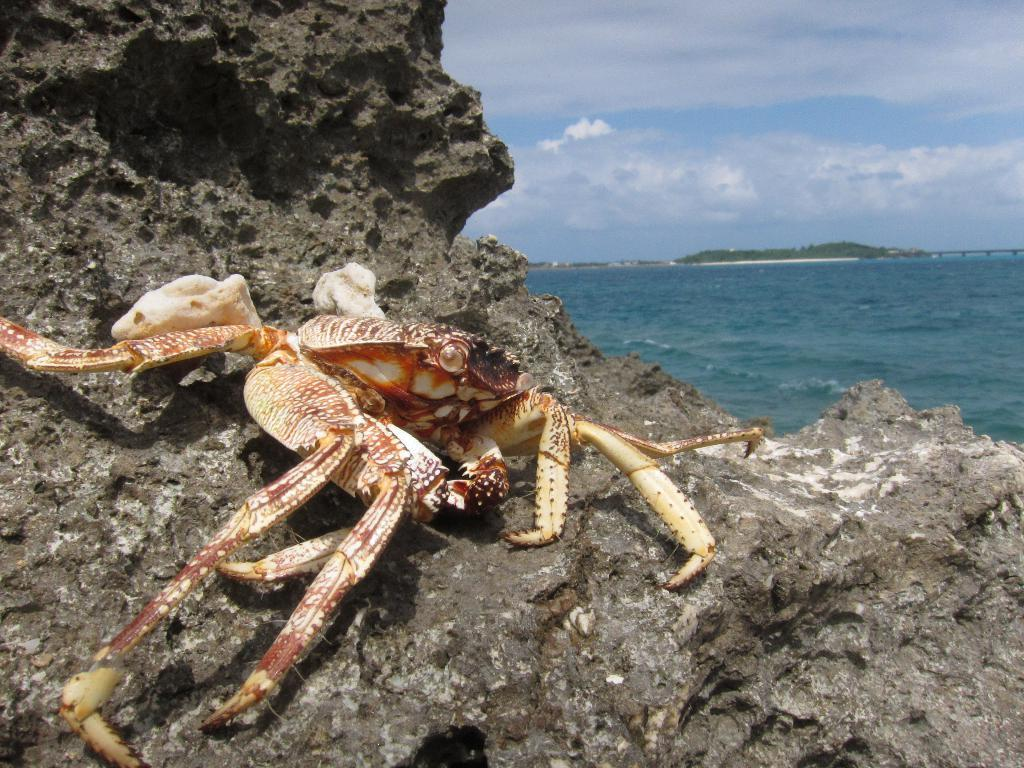What animal is on the rock in the image? There is a crab on a rock in the image. What is visible in the image besides the crab and rock? Water is visible in the image. What can be seen in the background of the image? The sky is visible in the background of the image. What is the condition of the sky in the image? Clouds are present in the sky. What type of nail is being used by the crab to climb the rock in the image? There is no nail present in the image, and the crab is not using any tool to climb the rock. 